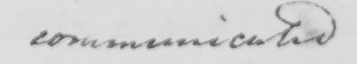Please provide the text content of this handwritten line. communicated 